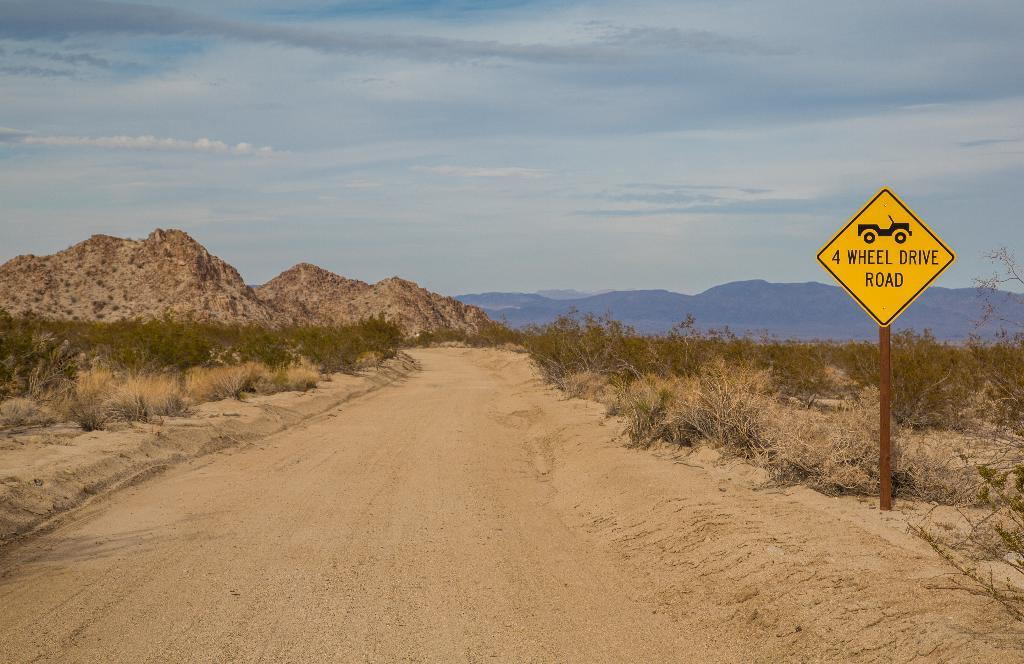<image>
Present a compact description of the photo's key features. Yellow sign in a desert which says "4 wheel drive road". 